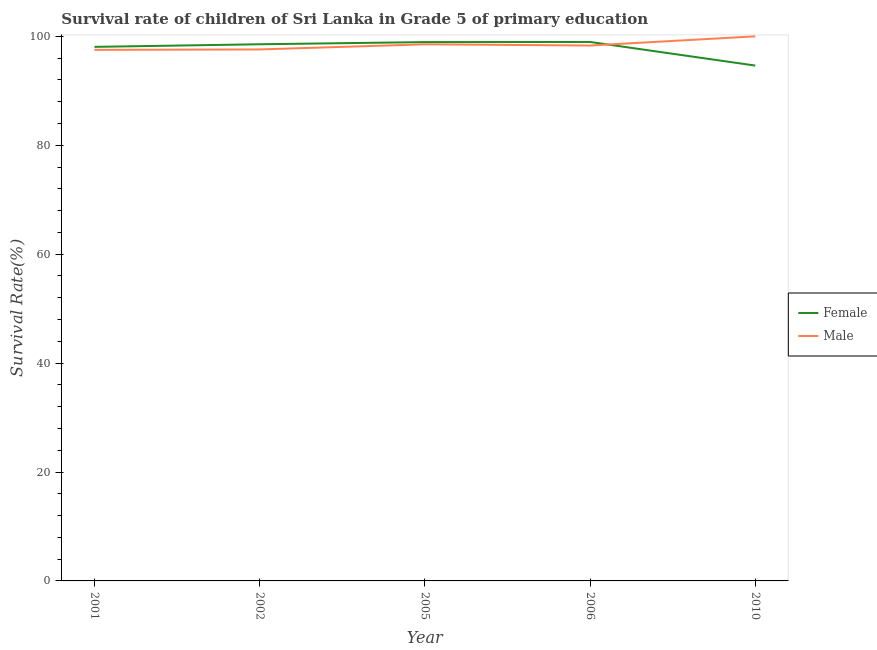Does the line corresponding to survival rate of female students in primary education intersect with the line corresponding to survival rate of male students in primary education?
Keep it short and to the point. Yes. Is the number of lines equal to the number of legend labels?
Provide a short and direct response. Yes. What is the survival rate of female students in primary education in 2005?
Offer a terse response. 98.94. Across all years, what is the maximum survival rate of female students in primary education?
Ensure brevity in your answer.  98.97. Across all years, what is the minimum survival rate of male students in primary education?
Offer a terse response. 97.52. What is the total survival rate of male students in primary education in the graph?
Keep it short and to the point. 491.96. What is the difference between the survival rate of male students in primary education in 2002 and that in 2006?
Ensure brevity in your answer.  -0.72. What is the difference between the survival rate of male students in primary education in 2001 and the survival rate of female students in primary education in 2010?
Your answer should be very brief. 2.89. What is the average survival rate of female students in primary education per year?
Your answer should be compact. 97.83. In the year 2006, what is the difference between the survival rate of female students in primary education and survival rate of male students in primary education?
Offer a terse response. 0.66. In how many years, is the survival rate of female students in primary education greater than 92 %?
Your answer should be very brief. 5. What is the ratio of the survival rate of female students in primary education in 2005 to that in 2006?
Provide a succinct answer. 1. Is the difference between the survival rate of male students in primary education in 2005 and 2006 greater than the difference between the survival rate of female students in primary education in 2005 and 2006?
Ensure brevity in your answer.  Yes. What is the difference between the highest and the second highest survival rate of female students in primary education?
Your answer should be compact. 0.02. What is the difference between the highest and the lowest survival rate of female students in primary education?
Make the answer very short. 4.34. Is the sum of the survival rate of female students in primary education in 2002 and 2010 greater than the maximum survival rate of male students in primary education across all years?
Your response must be concise. Yes. Does the survival rate of female students in primary education monotonically increase over the years?
Provide a short and direct response. No. Is the survival rate of female students in primary education strictly greater than the survival rate of male students in primary education over the years?
Give a very brief answer. No. Is the survival rate of male students in primary education strictly less than the survival rate of female students in primary education over the years?
Your response must be concise. No. How many years are there in the graph?
Provide a short and direct response. 5. What is the difference between two consecutive major ticks on the Y-axis?
Your response must be concise. 20. Does the graph contain grids?
Offer a very short reply. No. How are the legend labels stacked?
Your answer should be very brief. Vertical. What is the title of the graph?
Keep it short and to the point. Survival rate of children of Sri Lanka in Grade 5 of primary education. Does "Diesel" appear as one of the legend labels in the graph?
Offer a very short reply. No. What is the label or title of the X-axis?
Offer a terse response. Year. What is the label or title of the Y-axis?
Offer a very short reply. Survival Rate(%). What is the Survival Rate(%) in Female in 2001?
Keep it short and to the point. 98.07. What is the Survival Rate(%) in Male in 2001?
Your response must be concise. 97.52. What is the Survival Rate(%) in Female in 2002?
Your response must be concise. 98.55. What is the Survival Rate(%) in Male in 2002?
Keep it short and to the point. 97.59. What is the Survival Rate(%) in Female in 2005?
Give a very brief answer. 98.94. What is the Survival Rate(%) in Male in 2005?
Your answer should be compact. 98.53. What is the Survival Rate(%) of Female in 2006?
Give a very brief answer. 98.97. What is the Survival Rate(%) in Male in 2006?
Your response must be concise. 98.31. What is the Survival Rate(%) of Female in 2010?
Provide a succinct answer. 94.63. What is the Survival Rate(%) of Male in 2010?
Your response must be concise. 100. Across all years, what is the maximum Survival Rate(%) of Female?
Provide a succinct answer. 98.97. Across all years, what is the maximum Survival Rate(%) of Male?
Provide a succinct answer. 100. Across all years, what is the minimum Survival Rate(%) in Female?
Give a very brief answer. 94.63. Across all years, what is the minimum Survival Rate(%) of Male?
Offer a very short reply. 97.52. What is the total Survival Rate(%) of Female in the graph?
Provide a succinct answer. 489.16. What is the total Survival Rate(%) in Male in the graph?
Provide a short and direct response. 491.96. What is the difference between the Survival Rate(%) of Female in 2001 and that in 2002?
Provide a short and direct response. -0.48. What is the difference between the Survival Rate(%) in Male in 2001 and that in 2002?
Give a very brief answer. -0.08. What is the difference between the Survival Rate(%) of Female in 2001 and that in 2005?
Provide a succinct answer. -0.88. What is the difference between the Survival Rate(%) of Male in 2001 and that in 2005?
Your answer should be compact. -1.02. What is the difference between the Survival Rate(%) in Female in 2001 and that in 2006?
Provide a succinct answer. -0.9. What is the difference between the Survival Rate(%) in Male in 2001 and that in 2006?
Provide a succinct answer. -0.79. What is the difference between the Survival Rate(%) in Female in 2001 and that in 2010?
Make the answer very short. 3.44. What is the difference between the Survival Rate(%) in Male in 2001 and that in 2010?
Ensure brevity in your answer.  -2.48. What is the difference between the Survival Rate(%) of Female in 2002 and that in 2005?
Offer a very short reply. -0.4. What is the difference between the Survival Rate(%) in Male in 2002 and that in 2005?
Your response must be concise. -0.94. What is the difference between the Survival Rate(%) of Female in 2002 and that in 2006?
Keep it short and to the point. -0.42. What is the difference between the Survival Rate(%) of Male in 2002 and that in 2006?
Your response must be concise. -0.72. What is the difference between the Survival Rate(%) of Female in 2002 and that in 2010?
Ensure brevity in your answer.  3.91. What is the difference between the Survival Rate(%) in Male in 2002 and that in 2010?
Provide a succinct answer. -2.41. What is the difference between the Survival Rate(%) in Female in 2005 and that in 2006?
Offer a terse response. -0.02. What is the difference between the Survival Rate(%) in Male in 2005 and that in 2006?
Offer a very short reply. 0.22. What is the difference between the Survival Rate(%) of Female in 2005 and that in 2010?
Make the answer very short. 4.31. What is the difference between the Survival Rate(%) of Male in 2005 and that in 2010?
Provide a succinct answer. -1.47. What is the difference between the Survival Rate(%) of Female in 2006 and that in 2010?
Provide a succinct answer. 4.34. What is the difference between the Survival Rate(%) in Male in 2006 and that in 2010?
Make the answer very short. -1.69. What is the difference between the Survival Rate(%) of Female in 2001 and the Survival Rate(%) of Male in 2002?
Your response must be concise. 0.47. What is the difference between the Survival Rate(%) in Female in 2001 and the Survival Rate(%) in Male in 2005?
Keep it short and to the point. -0.47. What is the difference between the Survival Rate(%) of Female in 2001 and the Survival Rate(%) of Male in 2006?
Provide a succinct answer. -0.24. What is the difference between the Survival Rate(%) of Female in 2001 and the Survival Rate(%) of Male in 2010?
Give a very brief answer. -1.93. What is the difference between the Survival Rate(%) of Female in 2002 and the Survival Rate(%) of Male in 2005?
Your answer should be very brief. 0.01. What is the difference between the Survival Rate(%) of Female in 2002 and the Survival Rate(%) of Male in 2006?
Offer a very short reply. 0.23. What is the difference between the Survival Rate(%) in Female in 2002 and the Survival Rate(%) in Male in 2010?
Ensure brevity in your answer.  -1.45. What is the difference between the Survival Rate(%) of Female in 2005 and the Survival Rate(%) of Male in 2006?
Ensure brevity in your answer.  0.63. What is the difference between the Survival Rate(%) in Female in 2005 and the Survival Rate(%) in Male in 2010?
Your answer should be compact. -1.06. What is the difference between the Survival Rate(%) of Female in 2006 and the Survival Rate(%) of Male in 2010?
Your answer should be very brief. -1.03. What is the average Survival Rate(%) of Female per year?
Your answer should be very brief. 97.83. What is the average Survival Rate(%) of Male per year?
Keep it short and to the point. 98.39. In the year 2001, what is the difference between the Survival Rate(%) in Female and Survival Rate(%) in Male?
Offer a very short reply. 0.55. In the year 2002, what is the difference between the Survival Rate(%) in Female and Survival Rate(%) in Male?
Give a very brief answer. 0.95. In the year 2005, what is the difference between the Survival Rate(%) in Female and Survival Rate(%) in Male?
Keep it short and to the point. 0.41. In the year 2006, what is the difference between the Survival Rate(%) of Female and Survival Rate(%) of Male?
Keep it short and to the point. 0.66. In the year 2010, what is the difference between the Survival Rate(%) in Female and Survival Rate(%) in Male?
Provide a succinct answer. -5.37. What is the ratio of the Survival Rate(%) in Female in 2001 to that in 2002?
Give a very brief answer. 1. What is the ratio of the Survival Rate(%) of Male in 2001 to that in 2005?
Your answer should be very brief. 0.99. What is the ratio of the Survival Rate(%) of Female in 2001 to that in 2006?
Your response must be concise. 0.99. What is the ratio of the Survival Rate(%) of Male in 2001 to that in 2006?
Offer a very short reply. 0.99. What is the ratio of the Survival Rate(%) of Female in 2001 to that in 2010?
Your answer should be compact. 1.04. What is the ratio of the Survival Rate(%) of Male in 2001 to that in 2010?
Ensure brevity in your answer.  0.98. What is the ratio of the Survival Rate(%) in Male in 2002 to that in 2005?
Your answer should be compact. 0.99. What is the ratio of the Survival Rate(%) in Female in 2002 to that in 2006?
Offer a terse response. 1. What is the ratio of the Survival Rate(%) of Male in 2002 to that in 2006?
Offer a terse response. 0.99. What is the ratio of the Survival Rate(%) of Female in 2002 to that in 2010?
Ensure brevity in your answer.  1.04. What is the ratio of the Survival Rate(%) of Male in 2002 to that in 2010?
Ensure brevity in your answer.  0.98. What is the ratio of the Survival Rate(%) in Female in 2005 to that in 2006?
Your answer should be compact. 1. What is the ratio of the Survival Rate(%) in Female in 2005 to that in 2010?
Provide a short and direct response. 1.05. What is the ratio of the Survival Rate(%) in Male in 2005 to that in 2010?
Your answer should be compact. 0.99. What is the ratio of the Survival Rate(%) in Female in 2006 to that in 2010?
Your answer should be compact. 1.05. What is the ratio of the Survival Rate(%) in Male in 2006 to that in 2010?
Offer a very short reply. 0.98. What is the difference between the highest and the second highest Survival Rate(%) in Female?
Your response must be concise. 0.02. What is the difference between the highest and the second highest Survival Rate(%) of Male?
Your answer should be very brief. 1.47. What is the difference between the highest and the lowest Survival Rate(%) of Female?
Offer a very short reply. 4.34. What is the difference between the highest and the lowest Survival Rate(%) of Male?
Your answer should be very brief. 2.48. 